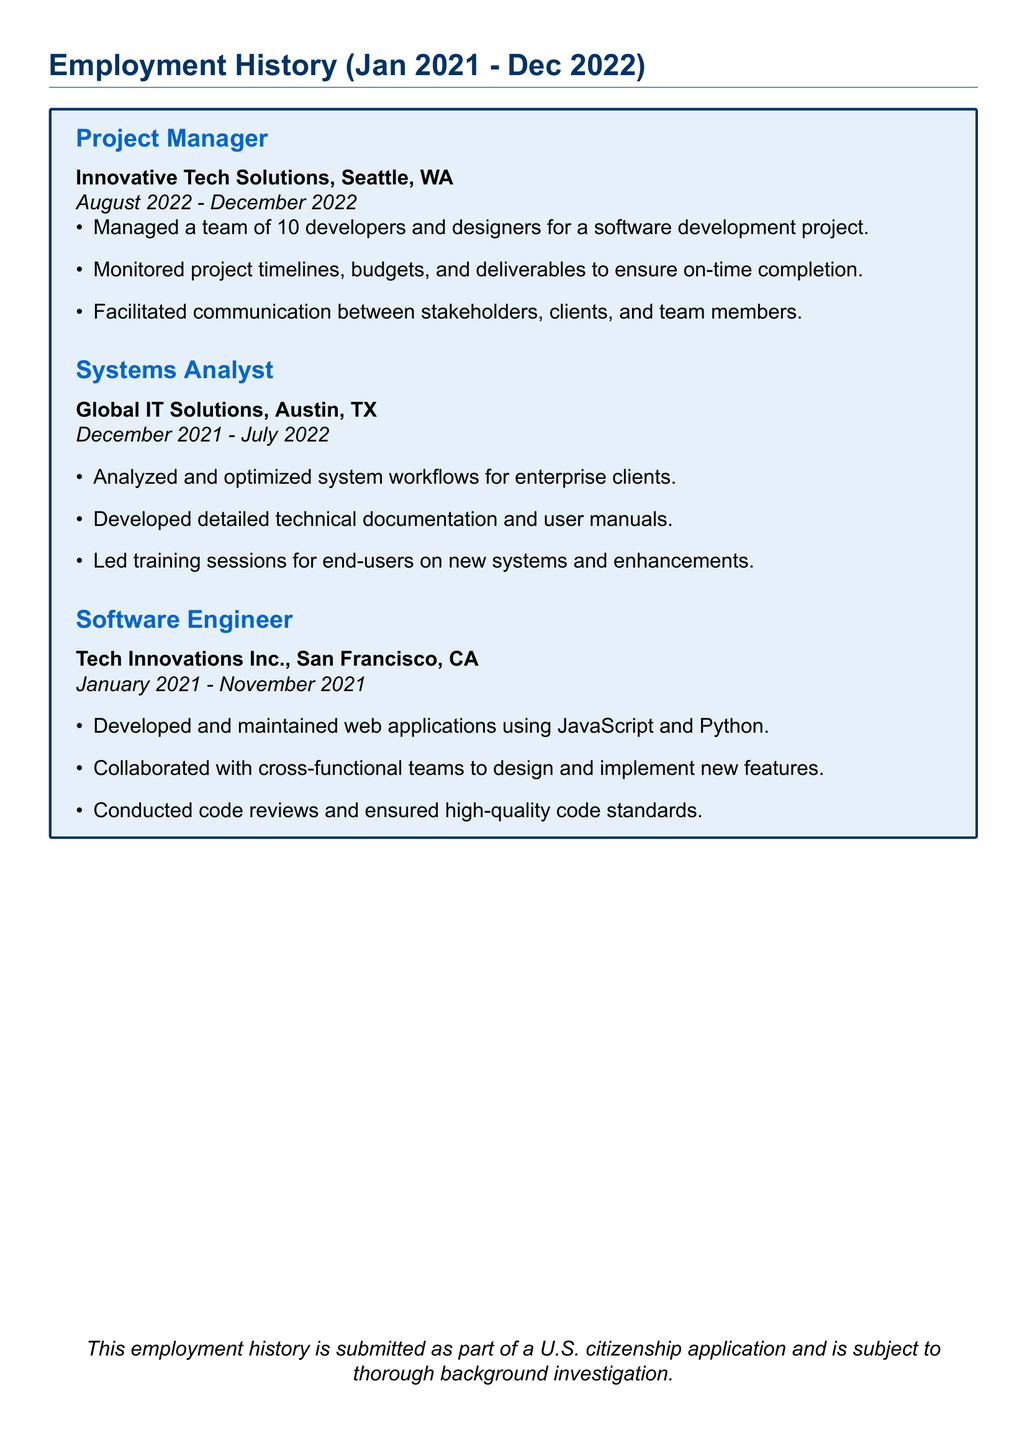What is the job title at Innovative Tech Solutions? The job title listed for Innovative Tech Solutions is Project Manager.
Answer: Project Manager What is the duration of employment at Global IT Solutions? The duration of employment at Global IT Solutions is from December 2021 to July 2022.
Answer: December 2021 - July 2022 How many developers and designers were managed in the last position? The document states that 10 developers and designers were managed in the last position.
Answer: 10 Which city is Tech Innovations Inc. located in? Tech Innovations Inc. is located in San Francisco, CA.
Answer: San Francisco, CA What primary programming languages were used by the Software Engineer? The primary programming languages used by the Software Engineer were JavaScript and Python.
Answer: JavaScript and Python In which month did the employment as Project Manager start? The employment as Project Manager started in August 2022.
Answer: August 2022 What is the total duration of employment listed in the document? The total duration includes three positions: January 2021 to December 2022, which sums up to approximately two years.
Answer: Approximately two years What was the last job title listed in the employment history? The last job title listed in the employment history is Project Manager.
Answer: Project Manager 